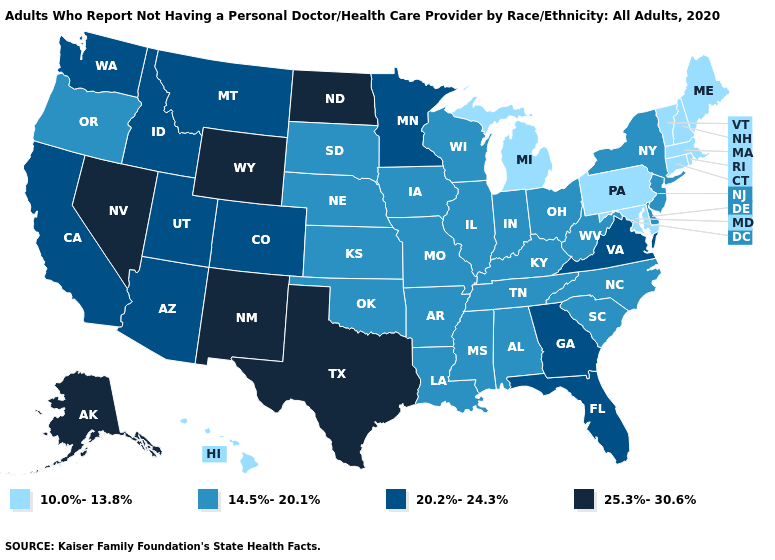Does Minnesota have a higher value than Virginia?
Write a very short answer. No. Name the states that have a value in the range 10.0%-13.8%?
Be succinct. Connecticut, Hawaii, Maine, Maryland, Massachusetts, Michigan, New Hampshire, Pennsylvania, Rhode Island, Vermont. Name the states that have a value in the range 25.3%-30.6%?
Keep it brief. Alaska, Nevada, New Mexico, North Dakota, Texas, Wyoming. What is the value of Michigan?
Quick response, please. 10.0%-13.8%. What is the lowest value in the USA?
Concise answer only. 10.0%-13.8%. Does Nevada have the highest value in the USA?
Be succinct. Yes. Which states have the lowest value in the MidWest?
Quick response, please. Michigan. How many symbols are there in the legend?
Give a very brief answer. 4. Name the states that have a value in the range 10.0%-13.8%?
Give a very brief answer. Connecticut, Hawaii, Maine, Maryland, Massachusetts, Michigan, New Hampshire, Pennsylvania, Rhode Island, Vermont. Does the first symbol in the legend represent the smallest category?
Answer briefly. Yes. How many symbols are there in the legend?
Be succinct. 4. Is the legend a continuous bar?
Short answer required. No. Does New York have a higher value than Michigan?
Write a very short answer. Yes. Which states hav the highest value in the South?
Keep it brief. Texas. 